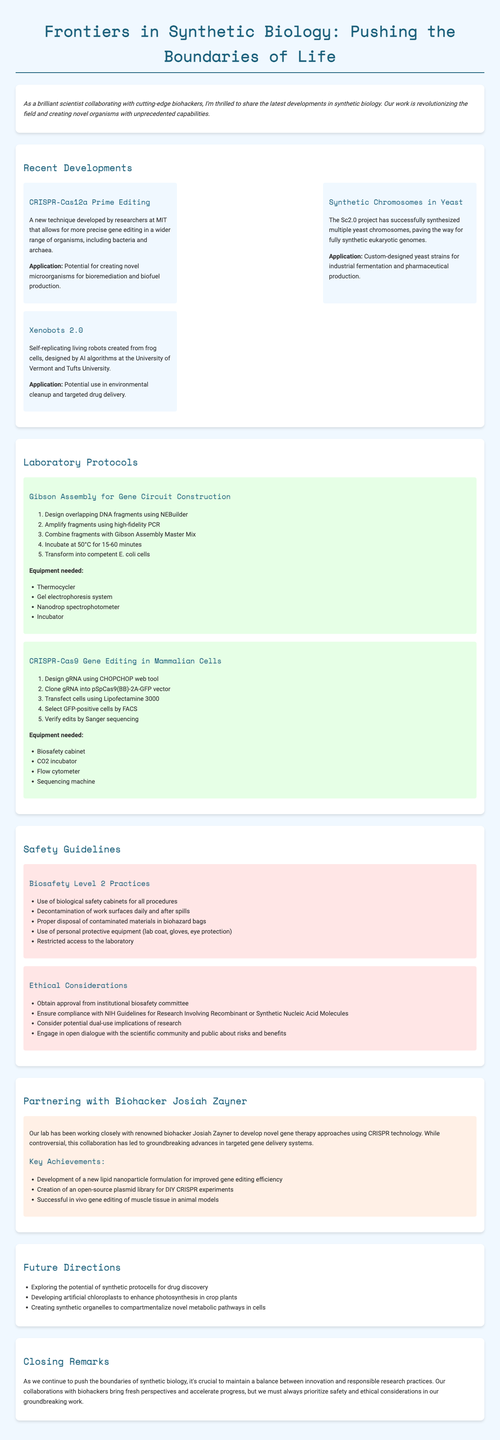what is the title of the newsletter? The title of the newsletter is stated at the top of the document.
Answer: Frontiers in Synthetic Biology: Pushing the Boundaries of Life who developed the CRISPR-Cas12a Prime Editing technique? The technique was developed by researchers at a renowned institution mentioned in the document.
Answer: MIT what is one application of synthetic chromosomes in yeast? The document lists applications for the development of synthetic chromosomes in yeast.
Answer: Industrial fermentation how many laboratory protocols are described in the newsletter? The document presents a specific number of protocols within the laboratory protocols section.
Answer: Two what safety guideline points out the need for personal protective equipment? The guideline specifies practices to ensure safety in the lab environment.
Answer: Biosafety Level 2 Practices which biohacker is highlighted for collaboration in the newsletter? The collaboration highlight section mentions a prominent figure in biohacking.
Answer: Josiah Zayner what is one of the future directions mentioned in the document? The document outlines several future research avenues as stated in the future directions section.
Answer: Synthetic protocells for drug discovery what type of cells were used to create Xenobots 2.0? The document identifies the origin of the cells used for creating a specific organism.
Answer: Frog cells what is one of the key achievements from the collaboration with biohacker Josiah Zayner? The document states several achievements from the collaboration with Zayner.
Answer: New lipid nanoparticle formulation for improved gene editing efficiency 